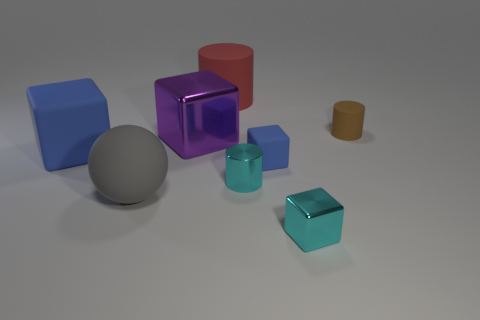Are there any other things that are the same color as the shiny cylinder?
Keep it short and to the point. Yes. Do the tiny rubber block and the big rubber cube have the same color?
Your response must be concise. Yes. Is the number of brown rubber cylinders less than the number of big matte things?
Provide a succinct answer. Yes. There is a cyan shiny cylinder; are there any tiny things in front of it?
Offer a terse response. Yes. Is the material of the red cylinder the same as the large blue block?
Provide a short and direct response. Yes. The metallic object that is the same shape as the small brown rubber thing is what color?
Your response must be concise. Cyan. Does the matte cube to the right of the large sphere have the same color as the small rubber cylinder?
Your response must be concise. No. The shiny thing that is the same color as the tiny metallic cylinder is what shape?
Provide a short and direct response. Cube. What number of brown cylinders are made of the same material as the purple block?
Offer a very short reply. 0. What number of cyan shiny cylinders are left of the brown rubber cylinder?
Keep it short and to the point. 1. 